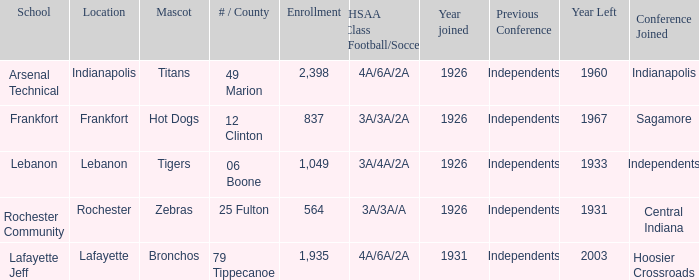What is the highest enrollment for rochester community school? 564.0. 